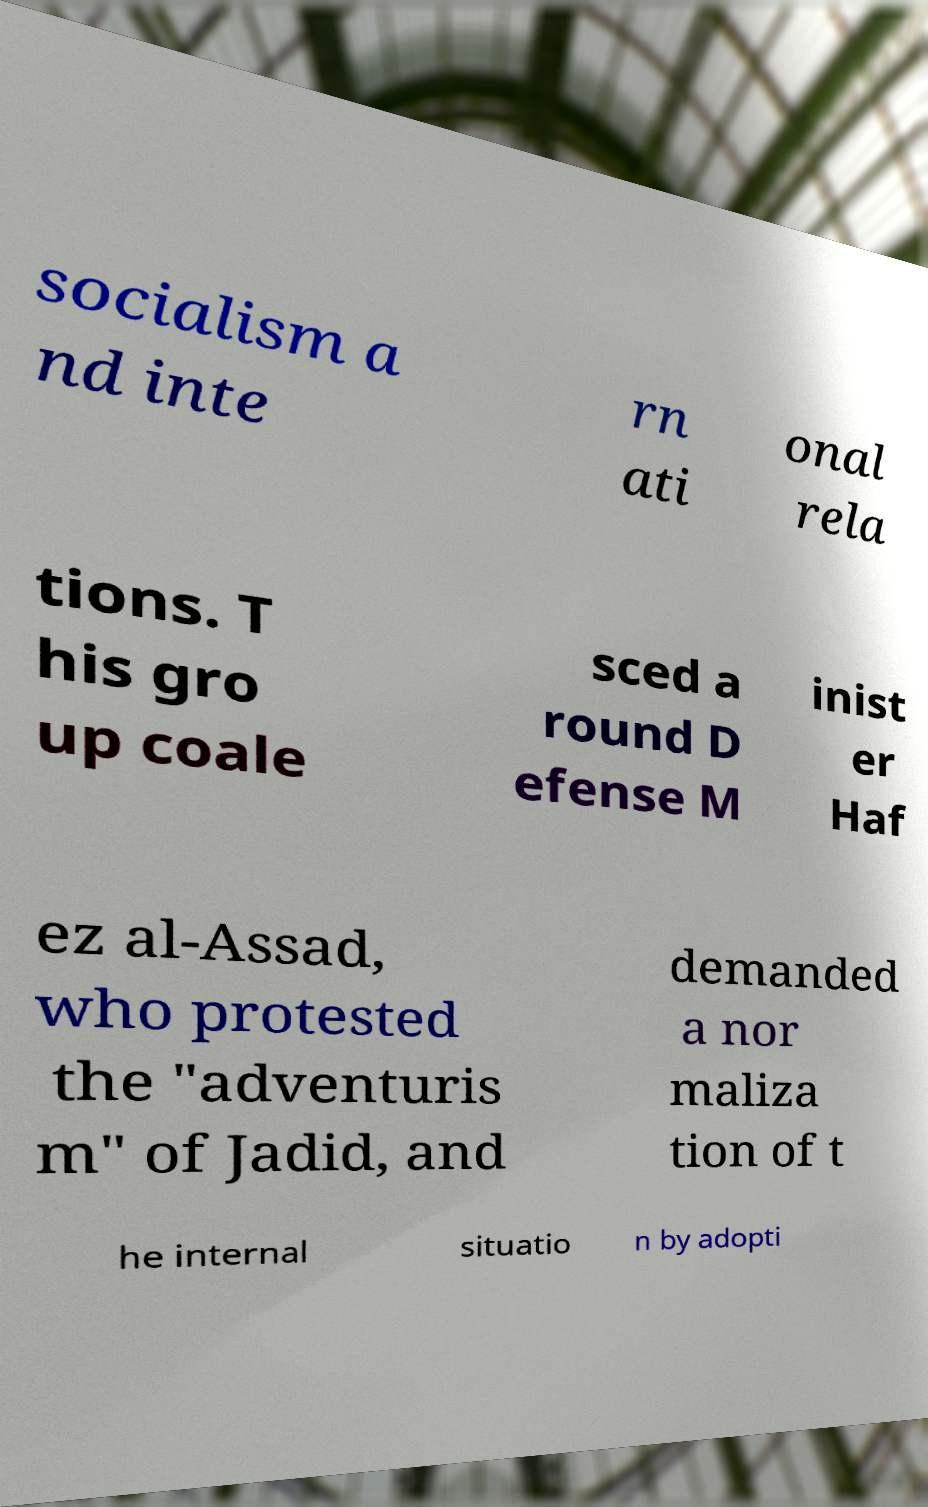I need the written content from this picture converted into text. Can you do that? socialism a nd inte rn ati onal rela tions. T his gro up coale sced a round D efense M inist er Haf ez al-Assad, who protested the "adventuris m" of Jadid, and demanded a nor maliza tion of t he internal situatio n by adopti 